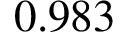Convert formula to latex. <formula><loc_0><loc_0><loc_500><loc_500>0 . 9 8 3</formula> 